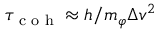<formula> <loc_0><loc_0><loc_500><loc_500>\tau _ { c o h } \approx h / m _ { \varphi } \Delta v ^ { 2 }</formula> 